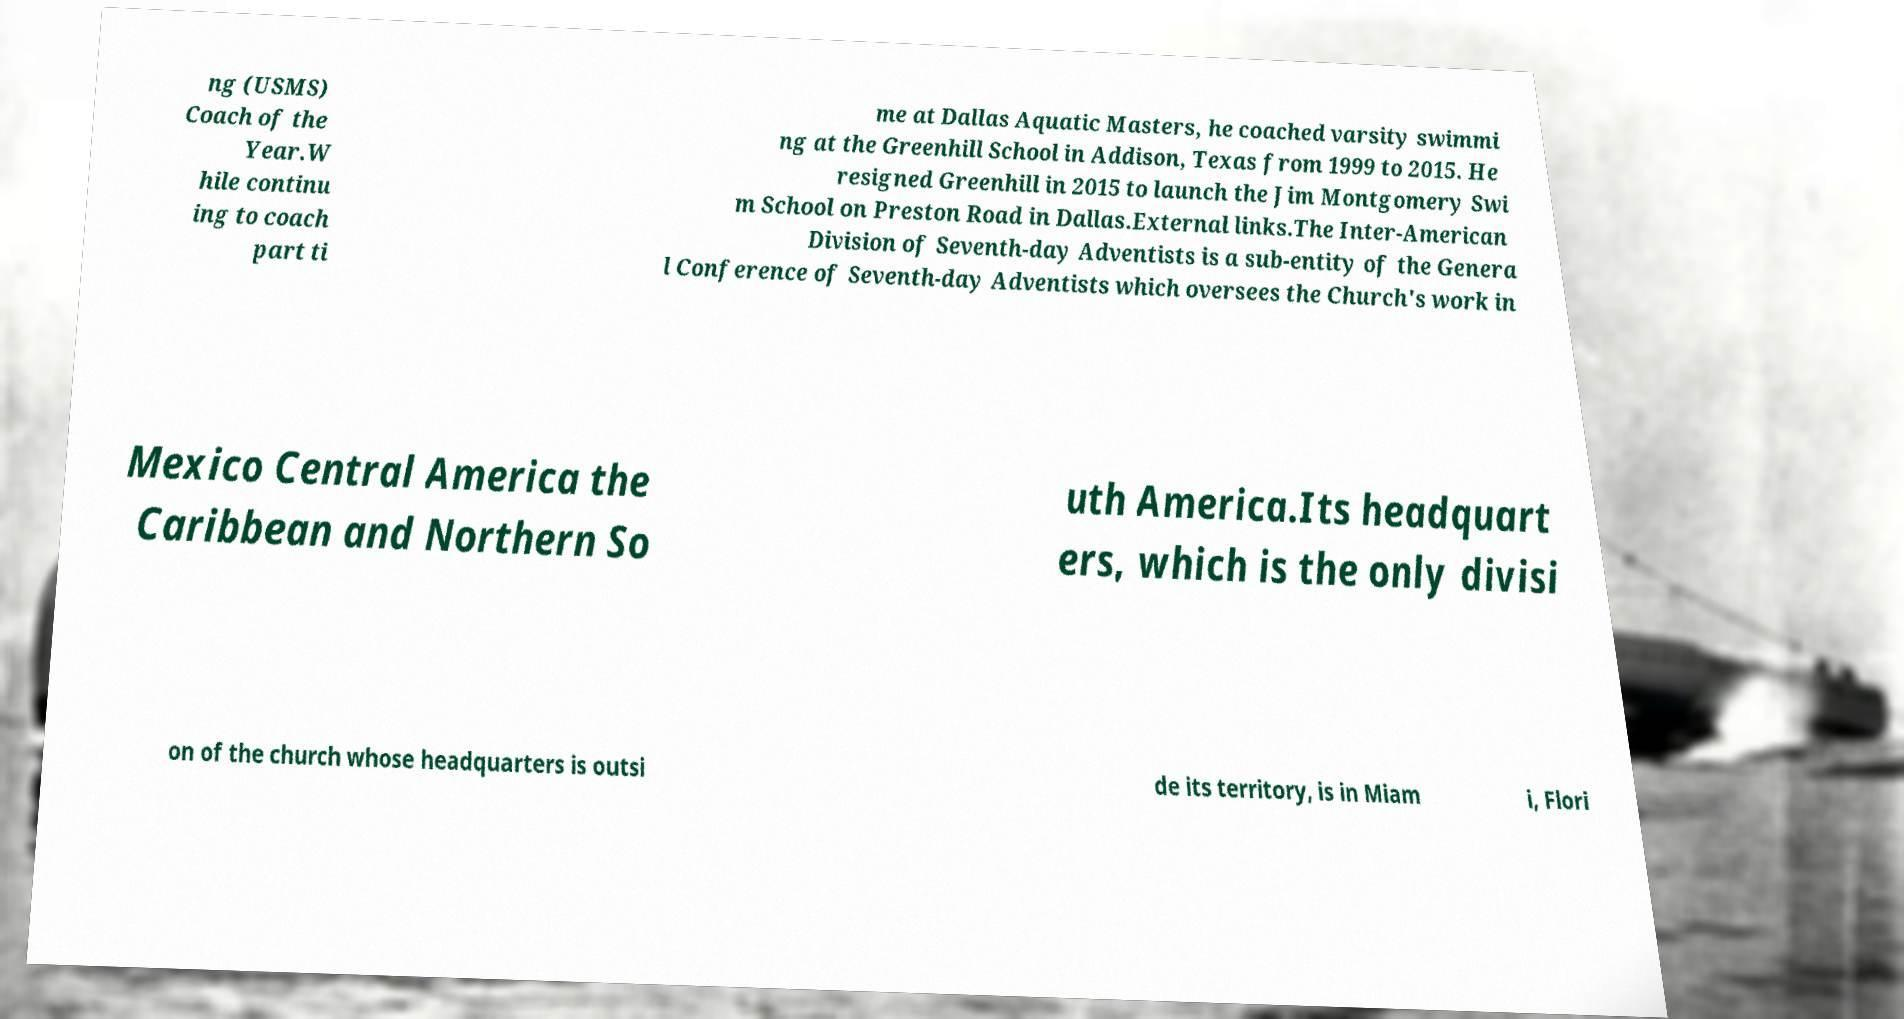For documentation purposes, I need the text within this image transcribed. Could you provide that? ng (USMS) Coach of the Year.W hile continu ing to coach part ti me at Dallas Aquatic Masters, he coached varsity swimmi ng at the Greenhill School in Addison, Texas from 1999 to 2015. He resigned Greenhill in 2015 to launch the Jim Montgomery Swi m School on Preston Road in Dallas.External links.The Inter-American Division of Seventh-day Adventists is a sub-entity of the Genera l Conference of Seventh-day Adventists which oversees the Church's work in Mexico Central America the Caribbean and Northern So uth America.Its headquart ers, which is the only divisi on of the church whose headquarters is outsi de its territory, is in Miam i, Flori 